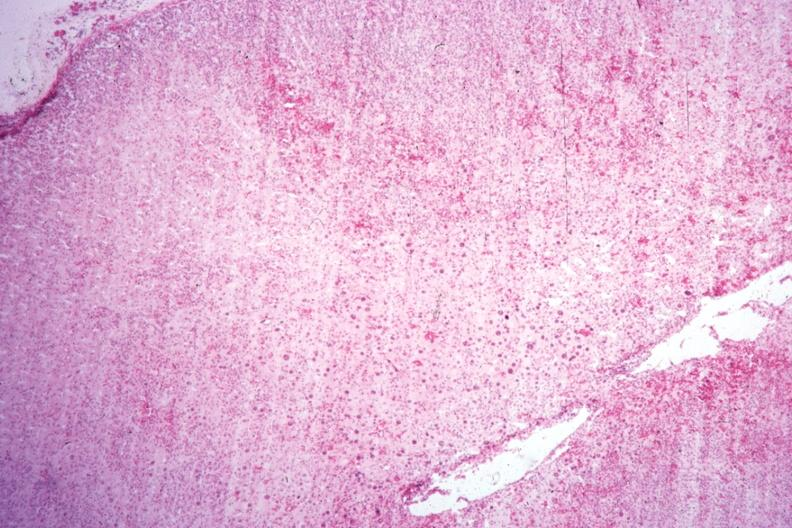what is present?
Answer the question using a single word or phrase. Adrenal 